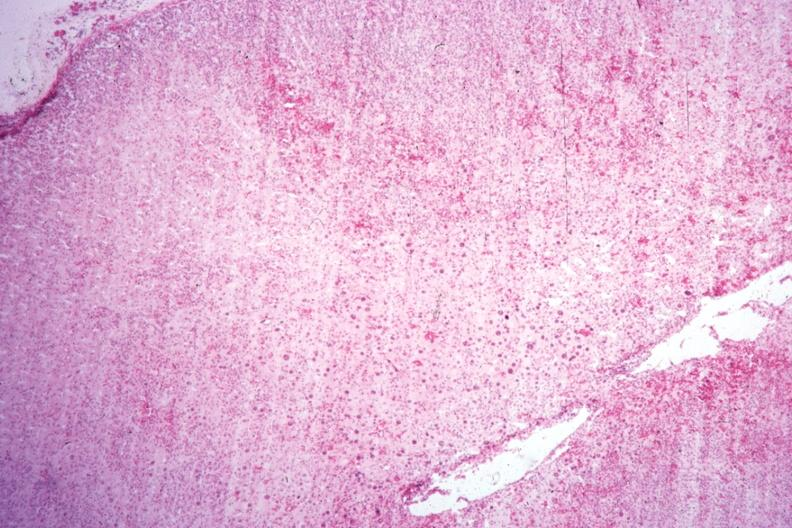what is present?
Answer the question using a single word or phrase. Adrenal 